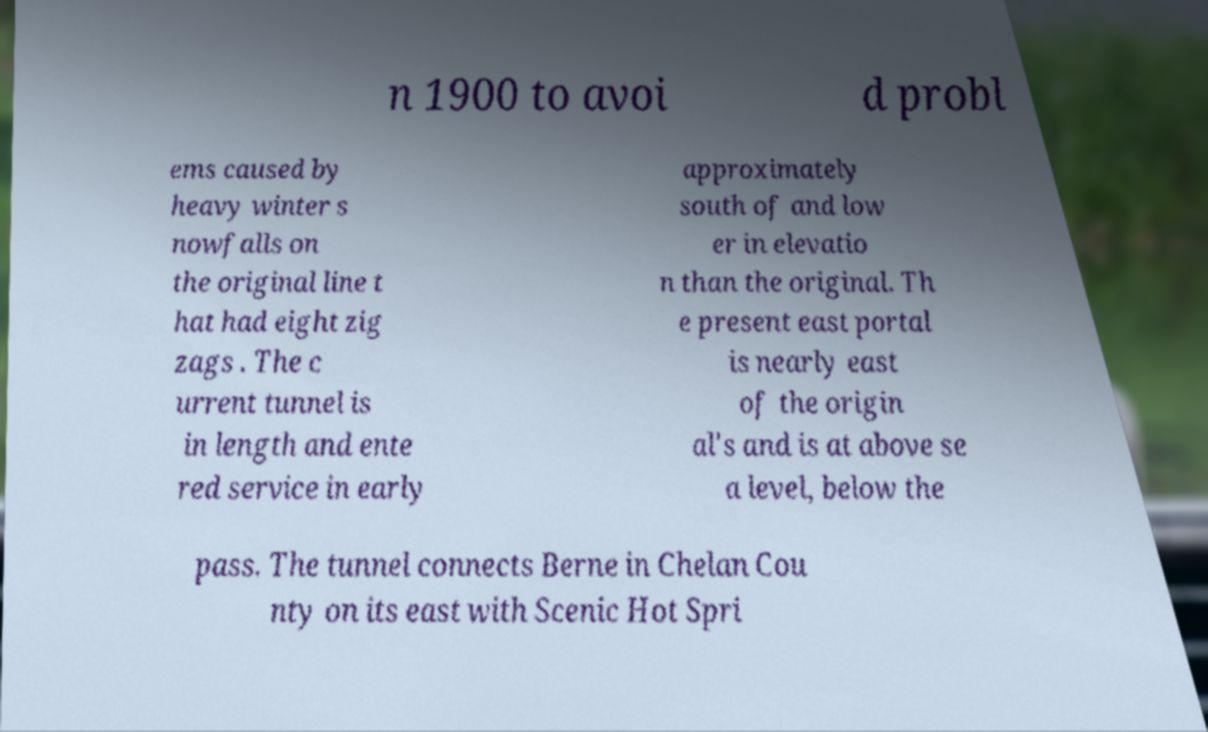There's text embedded in this image that I need extracted. Can you transcribe it verbatim? n 1900 to avoi d probl ems caused by heavy winter s nowfalls on the original line t hat had eight zig zags . The c urrent tunnel is in length and ente red service in early approximately south of and low er in elevatio n than the original. Th e present east portal is nearly east of the origin al's and is at above se a level, below the pass. The tunnel connects Berne in Chelan Cou nty on its east with Scenic Hot Spri 